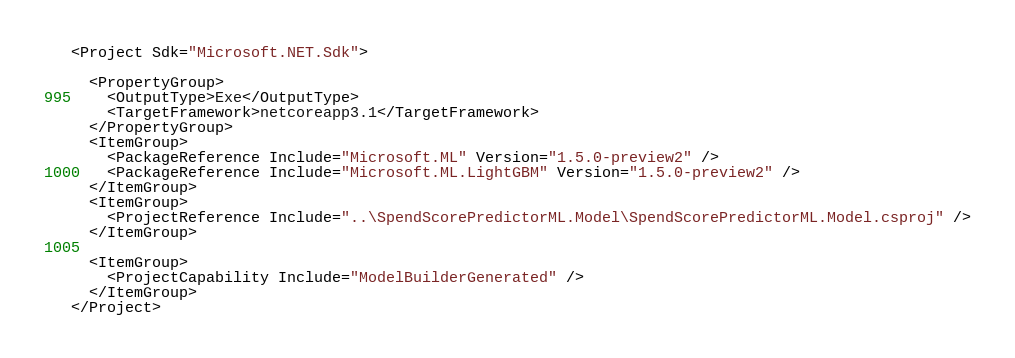Convert code to text. <code><loc_0><loc_0><loc_500><loc_500><_XML_><Project Sdk="Microsoft.NET.Sdk">

  <PropertyGroup>
    <OutputType>Exe</OutputType>
    <TargetFramework>netcoreapp3.1</TargetFramework>
  </PropertyGroup>
  <ItemGroup>
    <PackageReference Include="Microsoft.ML" Version="1.5.0-preview2" />
    <PackageReference Include="Microsoft.ML.LightGBM" Version="1.5.0-preview2" />
  </ItemGroup>
  <ItemGroup>
    <ProjectReference Include="..\SpendScorePredictorML.Model\SpendScorePredictorML.Model.csproj" />
  </ItemGroup>

  <ItemGroup>
    <ProjectCapability Include="ModelBuilderGenerated" />
  </ItemGroup>
</Project>
</code> 